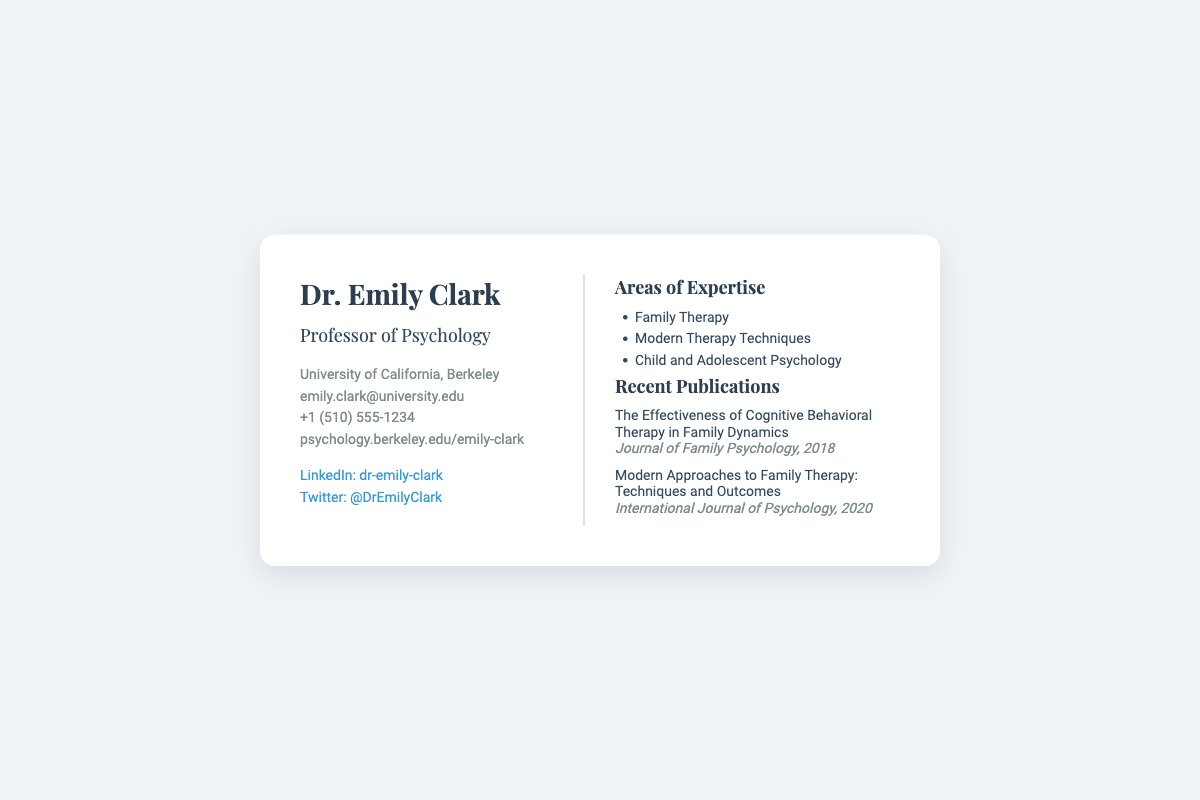What is the name of the professor? The document states that her name is Dr. Emily Clark.
Answer: Dr. Emily Clark What is the email address provided? The document lists the email as emily.clark@university.edu.
Answer: emily.clark@university.edu Which university is Dr. Emily Clark affiliated with? The document mentions the University of California, Berkeley as her affiliation.
Answer: University of California, Berkeley What is one area of expertise listed? The document indicates areas such as Family Therapy as her expertise.
Answer: Family Therapy What is the phone number provided? The document includes a phone number: +1 (510) 555-1234.
Answer: +1 (510) 555-1234 In which year was the publication on Cognitive Behavioral Therapy released? The document shows that the publication was released in 2018.
Answer: 2018 How many areas of expertise are listed? The document lists three areas of expertise under the “Areas of Expertise” section.
Answer: Three What social media platform is linked in the document? The document contains links to LinkedIn and Twitter.
Answer: LinkedIn and Twitter What is the title of one of Dr. Emily Clark's recent publications? The document states the title "Modern Approaches to Family Therapy: Techniques and Outcomes" as a publication.
Answer: Modern Approaches to Family Therapy: Techniques and Outcomes 